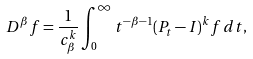Convert formula to latex. <formula><loc_0><loc_0><loc_500><loc_500>D ^ { \beta } f = \frac { 1 } { c ^ { k } _ { \beta } } \int _ { 0 } ^ { \infty } t ^ { - \beta - 1 } ( P _ { t } - I ) ^ { k } f \, d t ,</formula> 